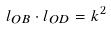<formula> <loc_0><loc_0><loc_500><loc_500>l _ { O B } \cdot l _ { O D } = k ^ { 2 }</formula> 